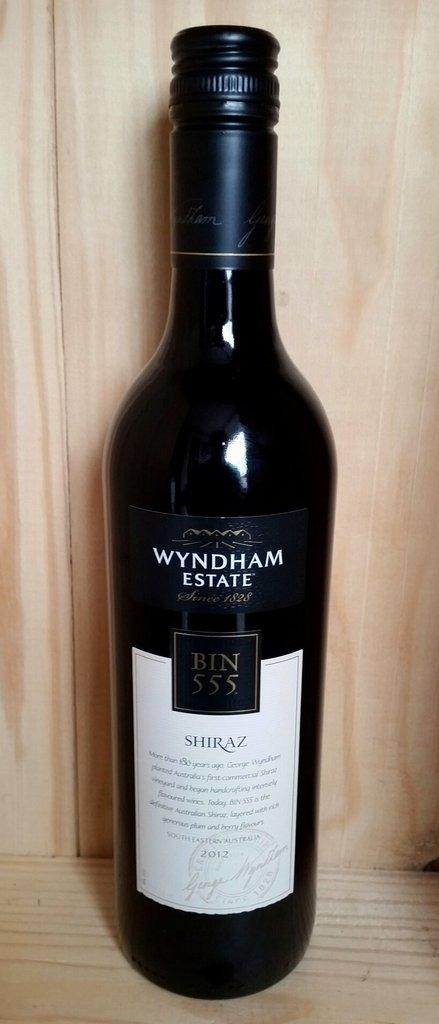<image>
Present a compact description of the photo's key features. A bottle of shiraz is from the brand Wyndham estate. 